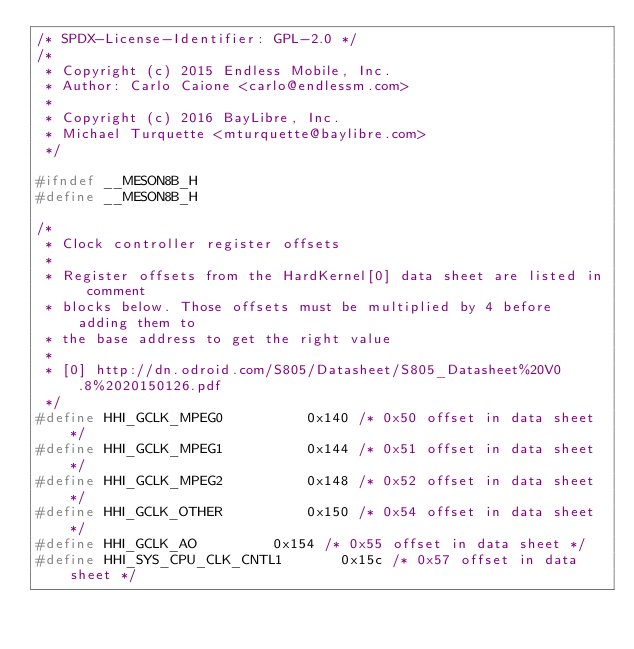Convert code to text. <code><loc_0><loc_0><loc_500><loc_500><_C_>/* SPDX-License-Identifier: GPL-2.0 */
/*
 * Copyright (c) 2015 Endless Mobile, Inc.
 * Author: Carlo Caione <carlo@endlessm.com>
 *
 * Copyright (c) 2016 BayLibre, Inc.
 * Michael Turquette <mturquette@baylibre.com>
 */

#ifndef __MESON8B_H
#define __MESON8B_H

/*
 * Clock controller register offsets
 *
 * Register offsets from the HardKernel[0] data sheet are listed in comment
 * blocks below. Those offsets must be multiplied by 4 before adding them to
 * the base address to get the right value
 *
 * [0] http://dn.odroid.com/S805/Datasheet/S805_Datasheet%20V0.8%2020150126.pdf
 */
#define HHI_GCLK_MPEG0			0x140 /* 0x50 offset in data sheet */
#define HHI_GCLK_MPEG1			0x144 /* 0x51 offset in data sheet */
#define HHI_GCLK_MPEG2			0x148 /* 0x52 offset in data sheet */
#define HHI_GCLK_OTHER			0x150 /* 0x54 offset in data sheet */
#define HHI_GCLK_AO			0x154 /* 0x55 offset in data sheet */
#define HHI_SYS_CPU_CLK_CNTL1		0x15c /* 0x57 offset in data sheet */</code> 